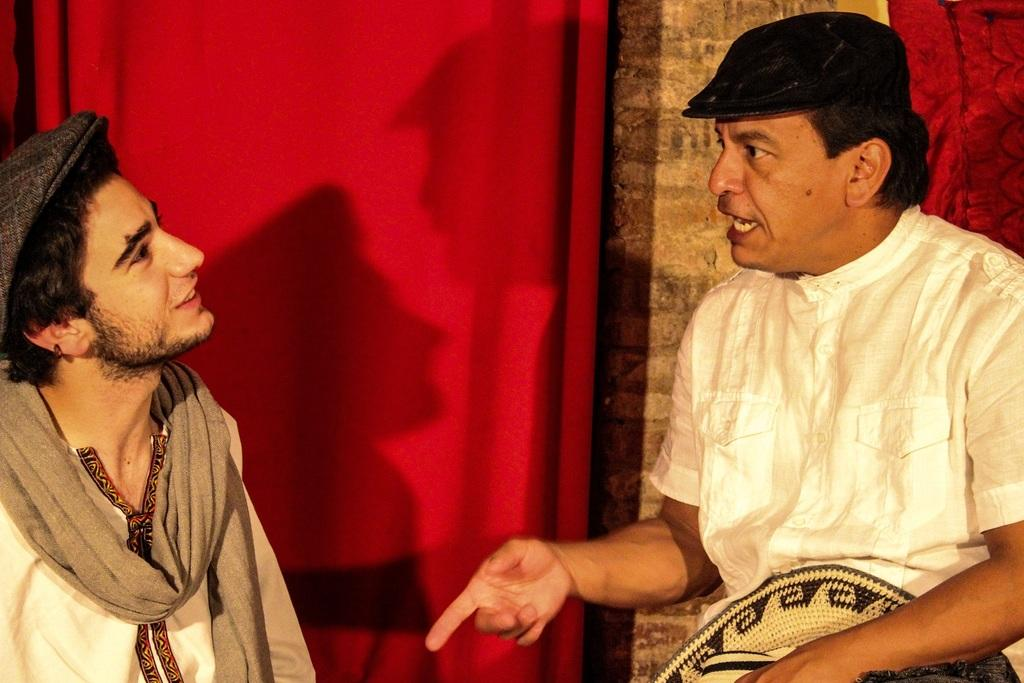How many people are in the image? There are two men in the image. What are the men wearing on their heads? The men are wearing caps on their heads. Can you describe any specific color or item in the image? Yes, there is a red color cloth in the image. What is the income of the men in the image? There is no information about the men's income in the image. How many matches are visible in the image? There are no matches present in the image. 